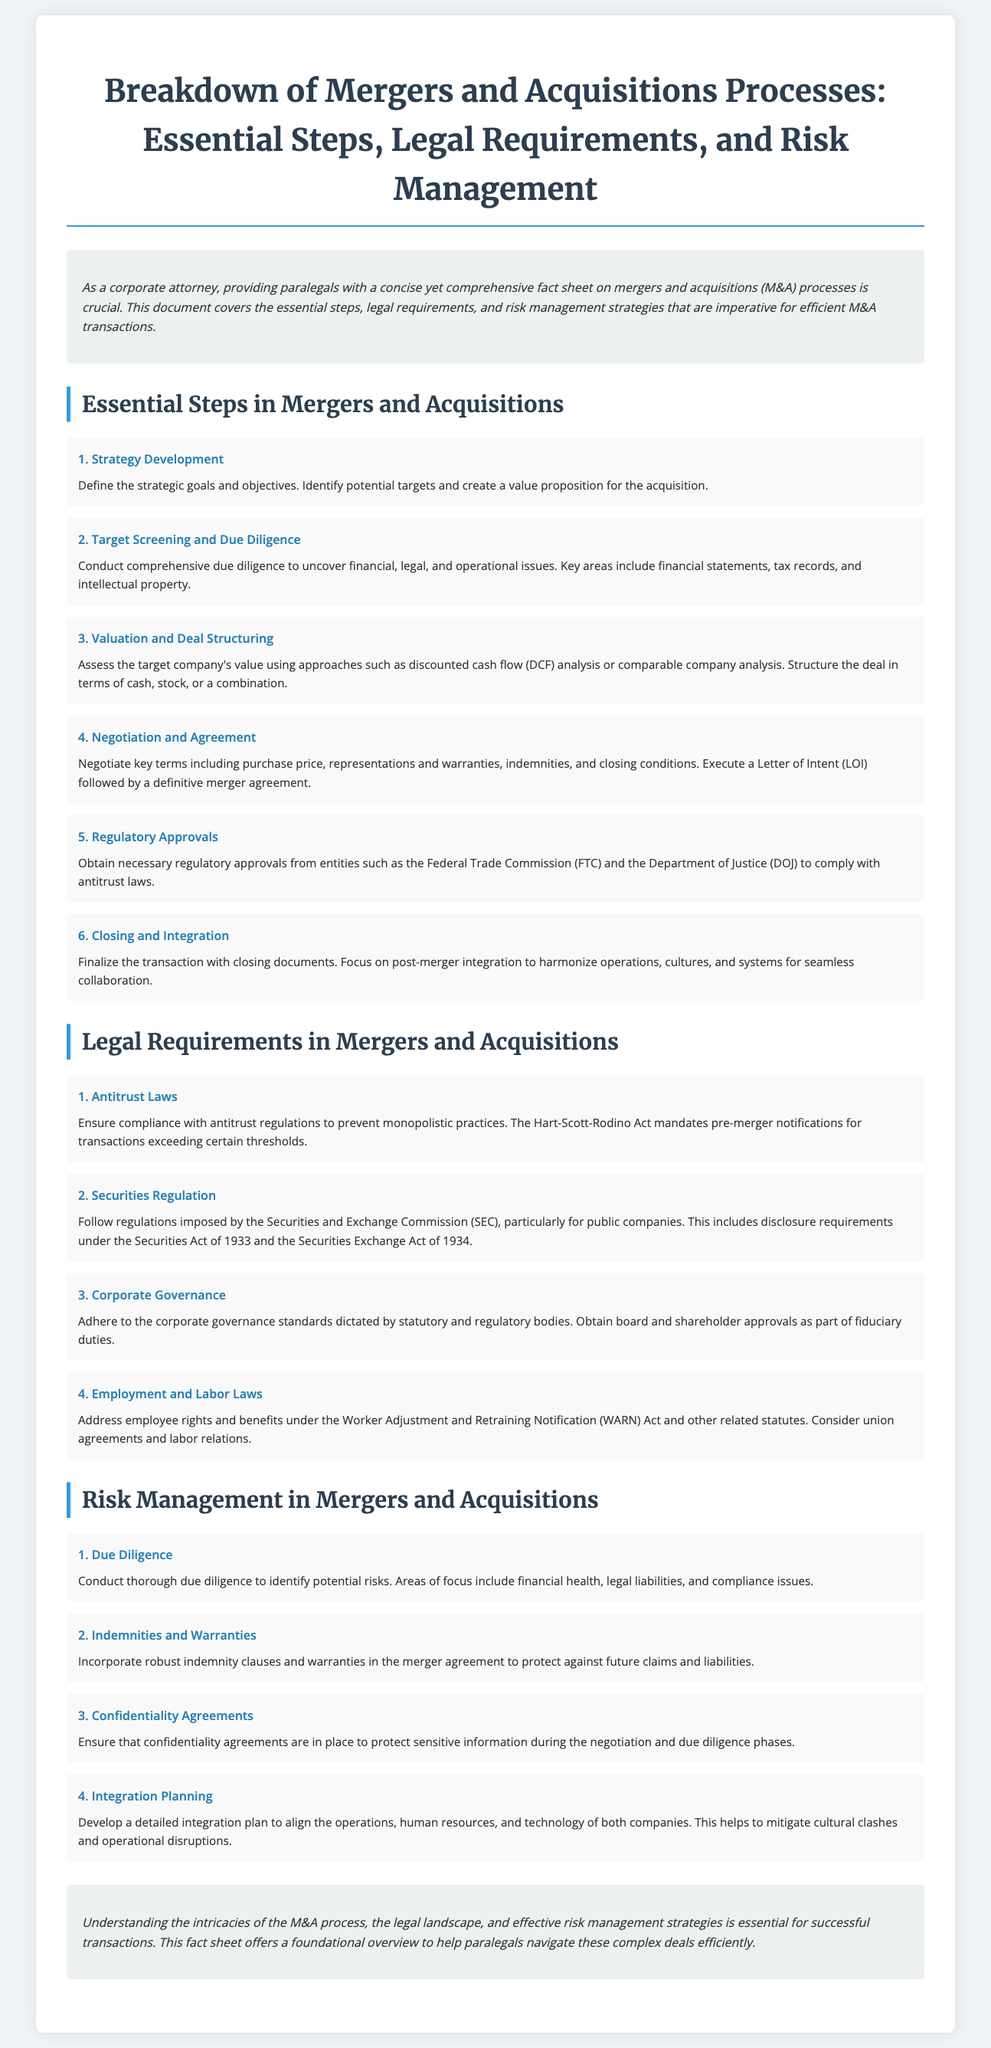What is the first step in the M&A process? The first step outlined in the document is to define the strategic goals and objectives and identify potential targets.
Answer: Strategy Development Which agency requires compliance with antitrust regulations? The document specifies that the Federal Trade Commission (FTC) requires compliance with antitrust regulations.
Answer: Federal Trade Commission (FTC) What act mandates pre-merger notifications? The document indicates that the Hart-Scott-Rodino Act mandates these notifications.
Answer: Hart-Scott-Rodino Act What is a key area of focus during due diligence? The document mentions financial health as a key area of focus during due diligence.
Answer: Financial health What should be included in the merger agreement to protect against future claims? The document states that robust indemnity clauses should be included for this purpose.
Answer: Indemnity clauses What does SEC stand for in relation to mergers and acquisitions? The document refers to the Securities and Exchange Commission, known by its acronym SEC.
Answer: Securities and Exchange Commission How many essential steps are outlined in the M&A process? The document lists a total of six essential steps in the M&A process.
Answer: Six What is the significance of confidentiality agreements during negotiations? The document notes that confidentiality agreements protect sensitive information during these phases.
Answer: Protect sensitive information What is the purpose of integration planning? Integration planning is meant to align the operations, human resources, and technology of both companies.
Answer: Align operations, human resources, and technology 